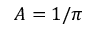<formula> <loc_0><loc_0><loc_500><loc_500>A = 1 / \pi</formula> 